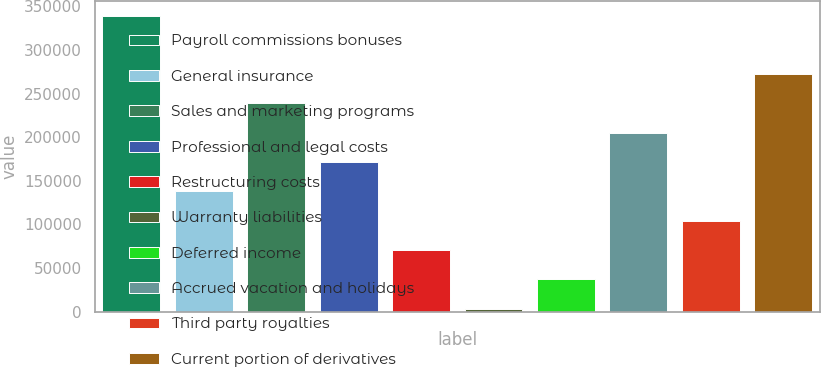Convert chart. <chart><loc_0><loc_0><loc_500><loc_500><bar_chart><fcel>Payroll commissions bonuses<fcel>General insurance<fcel>Sales and marketing programs<fcel>Professional and legal costs<fcel>Restructuring costs<fcel>Warranty liabilities<fcel>Deferred income<fcel>Accrued vacation and holidays<fcel>Third party royalties<fcel>Current portion of derivatives<nl><fcel>339308<fcel>137888<fcel>238598<fcel>171458<fcel>70748<fcel>3608<fcel>37178<fcel>205028<fcel>104318<fcel>272168<nl></chart> 